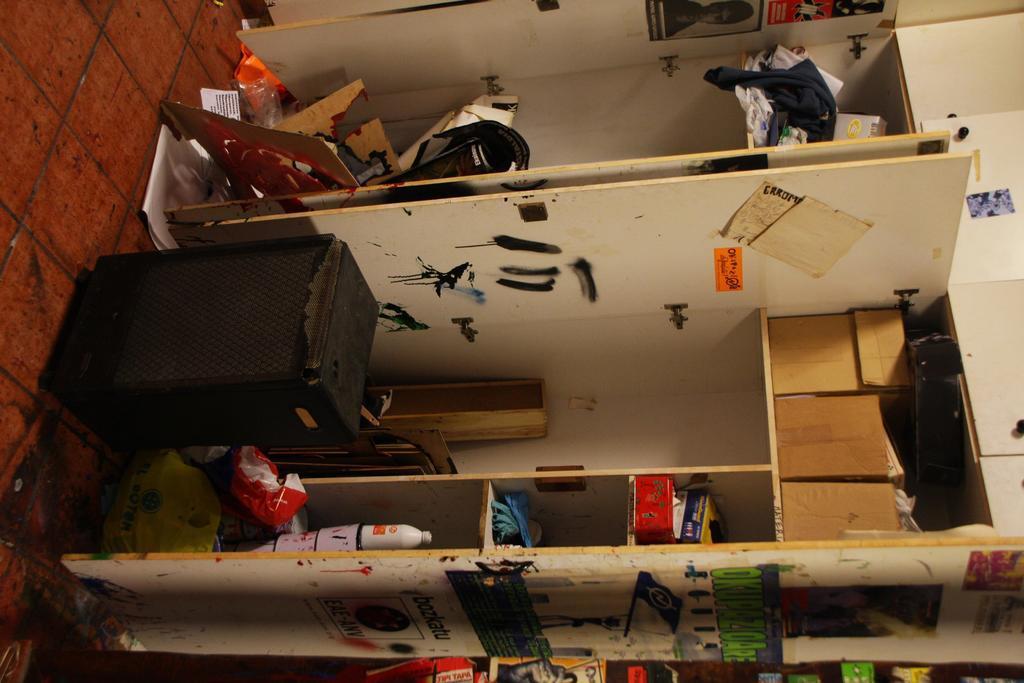In one or two sentences, can you explain what this image depicts? In this image there is a rack and we can see things placed in the rack. There are boxes. At the bottom we can see a speaker. There are posters pasted on the wall. 